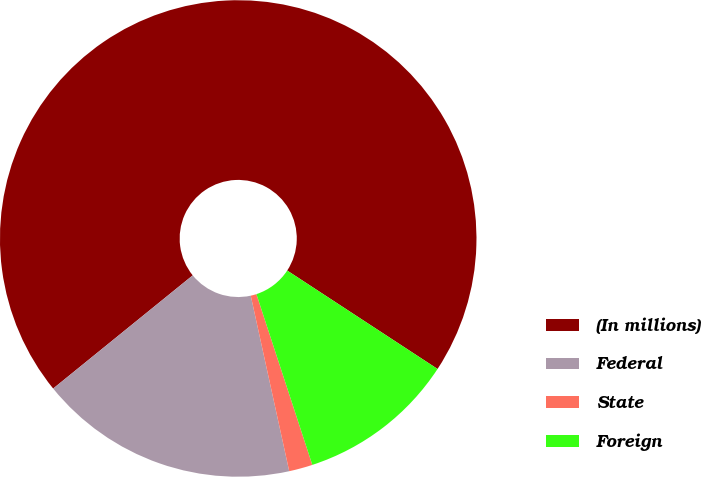Convert chart to OTSL. <chart><loc_0><loc_0><loc_500><loc_500><pie_chart><fcel>(In millions)<fcel>Federal<fcel>State<fcel>Foreign<nl><fcel>70.07%<fcel>17.59%<fcel>1.6%<fcel>10.74%<nl></chart> 